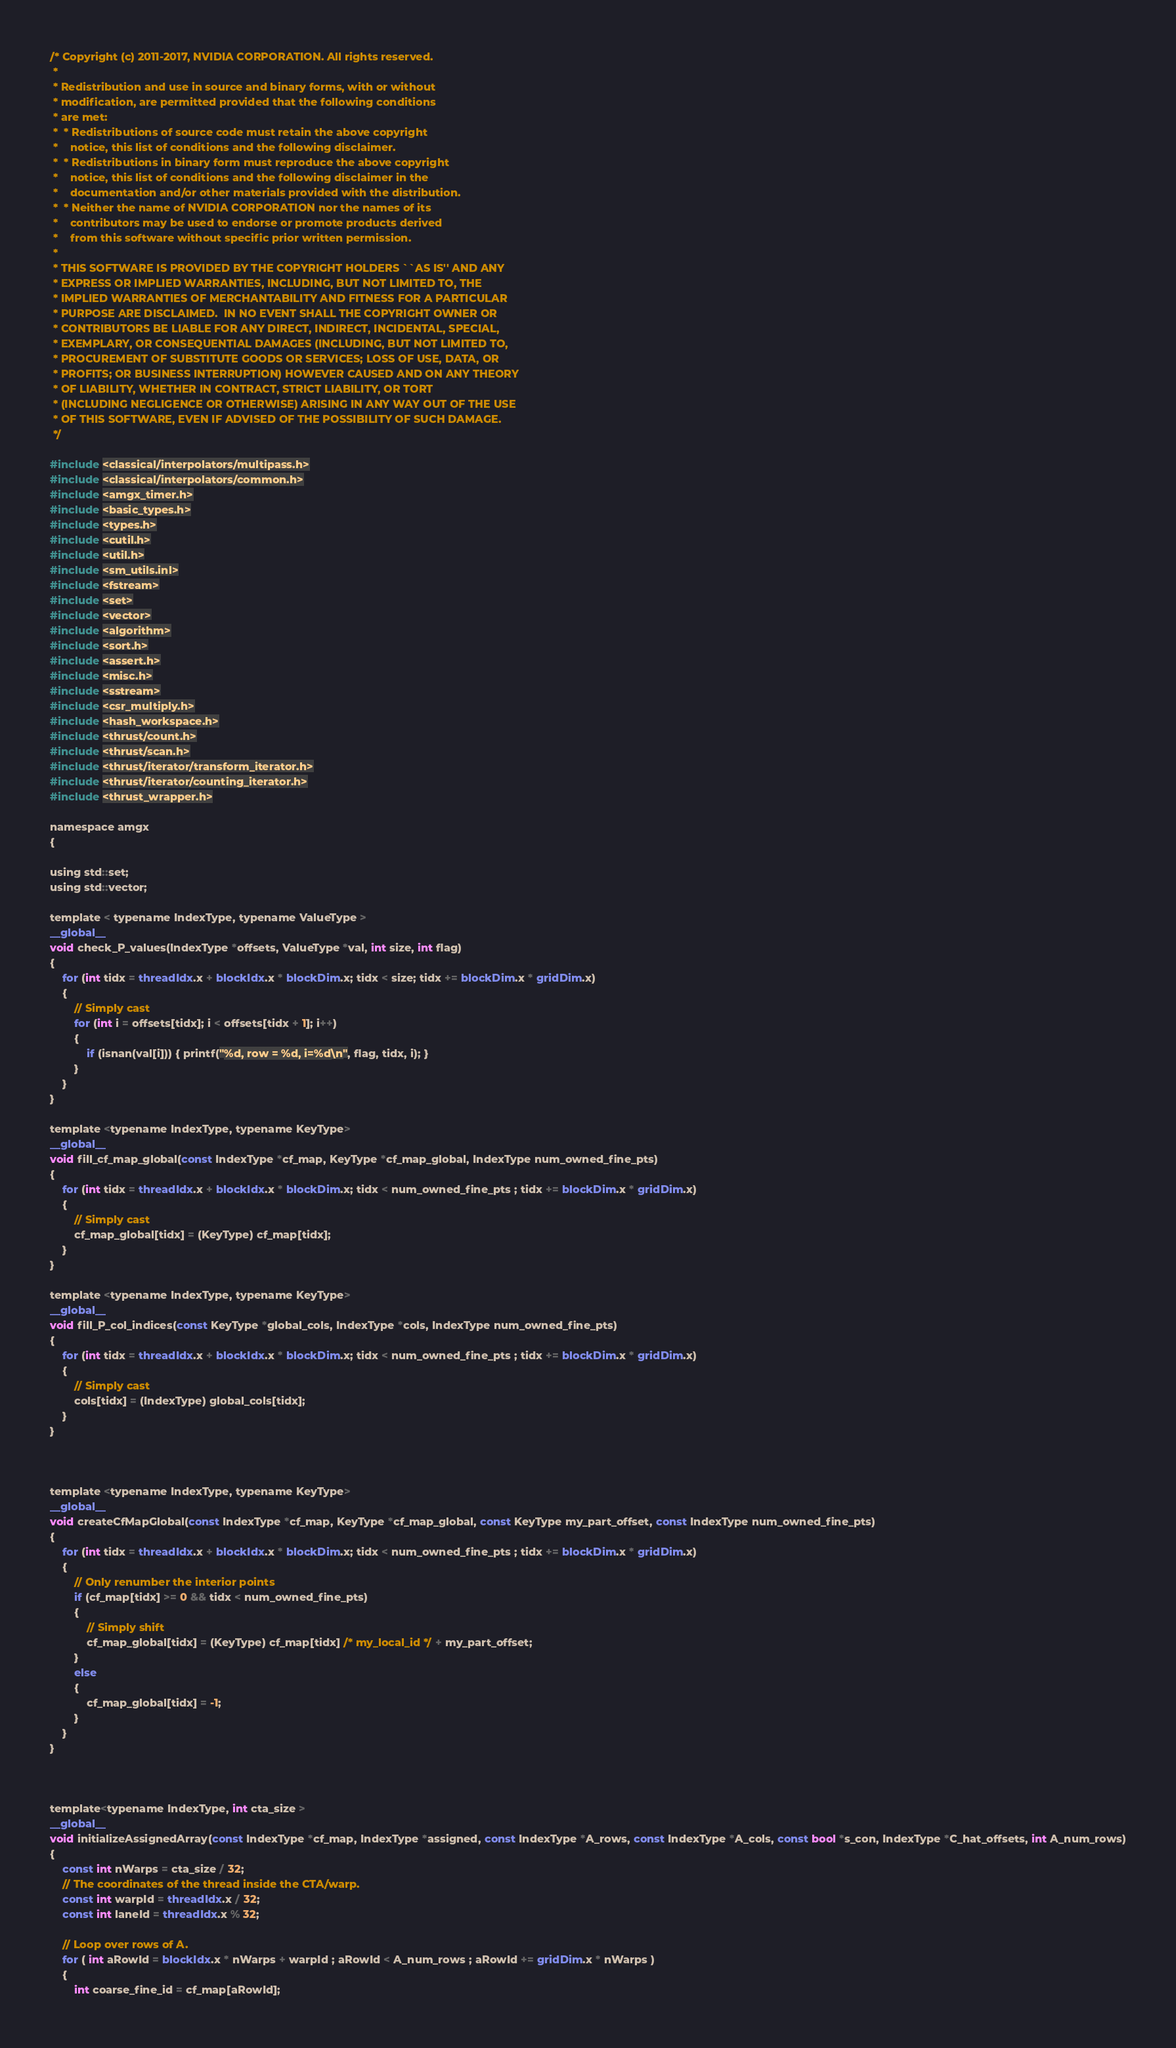Convert code to text. <code><loc_0><loc_0><loc_500><loc_500><_Cuda_>/* Copyright (c) 2011-2017, NVIDIA CORPORATION. All rights reserved.
 *
 * Redistribution and use in source and binary forms, with or without
 * modification, are permitted provided that the following conditions
 * are met:
 *  * Redistributions of source code must retain the above copyright
 *    notice, this list of conditions and the following disclaimer.
 *  * Redistributions in binary form must reproduce the above copyright
 *    notice, this list of conditions and the following disclaimer in the
 *    documentation and/or other materials provided with the distribution.
 *  * Neither the name of NVIDIA CORPORATION nor the names of its
 *    contributors may be used to endorse or promote products derived
 *    from this software without specific prior written permission.
 *
 * THIS SOFTWARE IS PROVIDED BY THE COPYRIGHT HOLDERS ``AS IS'' AND ANY
 * EXPRESS OR IMPLIED WARRANTIES, INCLUDING, BUT NOT LIMITED TO, THE
 * IMPLIED WARRANTIES OF MERCHANTABILITY AND FITNESS FOR A PARTICULAR
 * PURPOSE ARE DISCLAIMED.  IN NO EVENT SHALL THE COPYRIGHT OWNER OR
 * CONTRIBUTORS BE LIABLE FOR ANY DIRECT, INDIRECT, INCIDENTAL, SPECIAL,
 * EXEMPLARY, OR CONSEQUENTIAL DAMAGES (INCLUDING, BUT NOT LIMITED TO,
 * PROCUREMENT OF SUBSTITUTE GOODS OR SERVICES; LOSS OF USE, DATA, OR
 * PROFITS; OR BUSINESS INTERRUPTION) HOWEVER CAUSED AND ON ANY THEORY
 * OF LIABILITY, WHETHER IN CONTRACT, STRICT LIABILITY, OR TORT
 * (INCLUDING NEGLIGENCE OR OTHERWISE) ARISING IN ANY WAY OUT OF THE USE
 * OF THIS SOFTWARE, EVEN IF ADVISED OF THE POSSIBILITY OF SUCH DAMAGE.
 */

#include <classical/interpolators/multipass.h>
#include <classical/interpolators/common.h>
#include <amgx_timer.h>
#include <basic_types.h>
#include <types.h>
#include <cutil.h>
#include <util.h>
#include <sm_utils.inl>
#include <fstream>
#include <set>
#include <vector>
#include <algorithm>
#include <sort.h>
#include <assert.h>
#include <misc.h>
#include <sstream>
#include <csr_multiply.h>
#include <hash_workspace.h>
#include <thrust/count.h>
#include <thrust/scan.h>
#include <thrust/iterator/transform_iterator.h>
#include <thrust/iterator/counting_iterator.h>
#include <thrust_wrapper.h>

namespace amgx
{

using std::set;
using std::vector;

template < typename IndexType, typename ValueType >
__global__
void check_P_values(IndexType *offsets, ValueType *val, int size, int flag)
{
    for (int tidx = threadIdx.x + blockIdx.x * blockDim.x; tidx < size; tidx += blockDim.x * gridDim.x)
    {
        // Simply cast
        for (int i = offsets[tidx]; i < offsets[tidx + 1]; i++)
        {
            if (isnan(val[i])) { printf("%d, row = %d, i=%d\n", flag, tidx, i); }
        }
    }
}

template <typename IndexType, typename KeyType>
__global__
void fill_cf_map_global(const IndexType *cf_map, KeyType *cf_map_global, IndexType num_owned_fine_pts)
{
    for (int tidx = threadIdx.x + blockIdx.x * blockDim.x; tidx < num_owned_fine_pts ; tidx += blockDim.x * gridDim.x)
    {
        // Simply cast
        cf_map_global[tidx] = (KeyType) cf_map[tidx];
    }
}

template <typename IndexType, typename KeyType>
__global__
void fill_P_col_indices(const KeyType *global_cols, IndexType *cols, IndexType num_owned_fine_pts)
{
    for (int tidx = threadIdx.x + blockIdx.x * blockDim.x; tidx < num_owned_fine_pts ; tidx += blockDim.x * gridDim.x)
    {
        // Simply cast
        cols[tidx] = (IndexType) global_cols[tidx];
    }
}



template <typename IndexType, typename KeyType>
__global__
void createCfMapGlobal(const IndexType *cf_map, KeyType *cf_map_global, const KeyType my_part_offset, const IndexType num_owned_fine_pts)
{
    for (int tidx = threadIdx.x + blockIdx.x * blockDim.x; tidx < num_owned_fine_pts ; tidx += blockDim.x * gridDim.x)
    {
        // Only renumber the interior points
        if (cf_map[tidx] >= 0 && tidx < num_owned_fine_pts)
        {
            // Simply shift
            cf_map_global[tidx] = (KeyType) cf_map[tidx] /* my_local_id */ + my_part_offset;
        }
        else
        {
            cf_map_global[tidx] = -1;
        }
    }
}



template<typename IndexType, int cta_size >
__global__
void initializeAssignedArray(const IndexType *cf_map, IndexType *assigned, const IndexType *A_rows, const IndexType *A_cols, const bool *s_con, IndexType *C_hat_offsets, int A_num_rows)
{
    const int nWarps = cta_size / 32;
    // The coordinates of the thread inside the CTA/warp.
    const int warpId = threadIdx.x / 32;
    const int laneId = threadIdx.x % 32;

    // Loop over rows of A.
    for ( int aRowId = blockIdx.x * nWarps + warpId ; aRowId < A_num_rows ; aRowId += gridDim.x * nWarps )
    {
        int coarse_fine_id = cf_map[aRowId];
</code> 